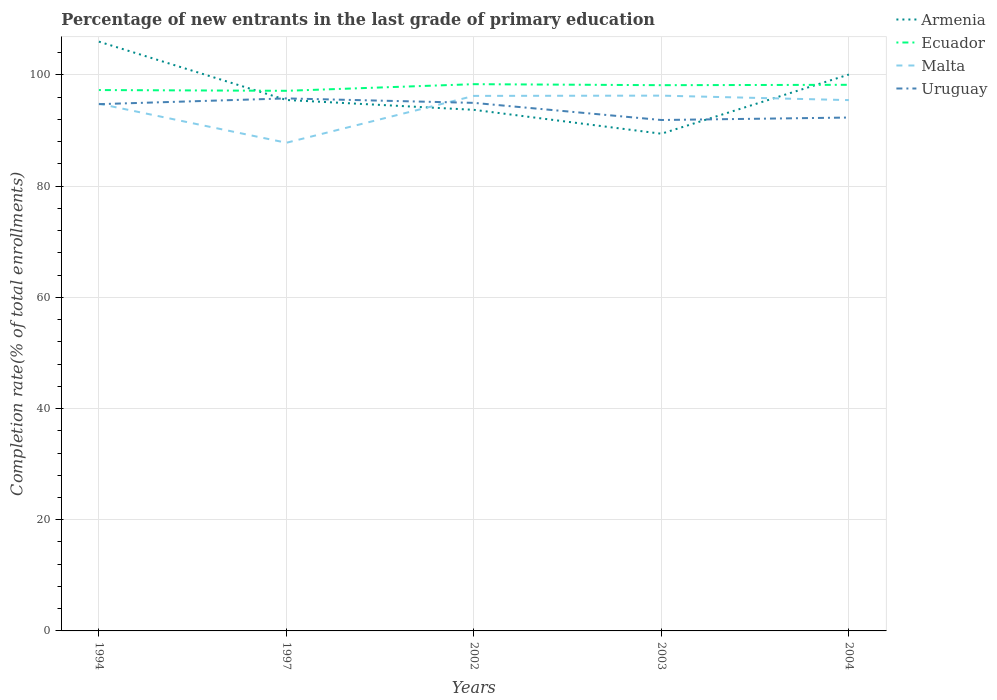Across all years, what is the maximum percentage of new entrants in Malta?
Your answer should be very brief. 87.8. In which year was the percentage of new entrants in Malta maximum?
Keep it short and to the point. 1997. What is the total percentage of new entrants in Uruguay in the graph?
Offer a terse response. 2.41. What is the difference between the highest and the second highest percentage of new entrants in Uruguay?
Offer a very short reply. 3.88. What is the difference between the highest and the lowest percentage of new entrants in Malta?
Provide a succinct answer. 4. Is the percentage of new entrants in Malta strictly greater than the percentage of new entrants in Armenia over the years?
Ensure brevity in your answer.  No. How many years are there in the graph?
Your answer should be compact. 5. What is the difference between two consecutive major ticks on the Y-axis?
Your response must be concise. 20. Does the graph contain any zero values?
Offer a terse response. No. Does the graph contain grids?
Offer a terse response. Yes. Where does the legend appear in the graph?
Offer a terse response. Top right. How many legend labels are there?
Keep it short and to the point. 4. What is the title of the graph?
Your answer should be compact. Percentage of new entrants in the last grade of primary education. Does "Uruguay" appear as one of the legend labels in the graph?
Your response must be concise. Yes. What is the label or title of the X-axis?
Make the answer very short. Years. What is the label or title of the Y-axis?
Provide a succinct answer. Completion rate(% of total enrollments). What is the Completion rate(% of total enrollments) of Armenia in 1994?
Your response must be concise. 105.99. What is the Completion rate(% of total enrollments) of Ecuador in 1994?
Offer a very short reply. 97.28. What is the Completion rate(% of total enrollments) of Malta in 1994?
Make the answer very short. 94.82. What is the Completion rate(% of total enrollments) of Uruguay in 1994?
Offer a terse response. 94.75. What is the Completion rate(% of total enrollments) of Armenia in 1997?
Give a very brief answer. 95.5. What is the Completion rate(% of total enrollments) of Ecuador in 1997?
Keep it short and to the point. 97.15. What is the Completion rate(% of total enrollments) of Malta in 1997?
Your response must be concise. 87.8. What is the Completion rate(% of total enrollments) of Uruguay in 1997?
Your response must be concise. 95.78. What is the Completion rate(% of total enrollments) of Armenia in 2002?
Keep it short and to the point. 93.73. What is the Completion rate(% of total enrollments) in Ecuador in 2002?
Offer a very short reply. 98.34. What is the Completion rate(% of total enrollments) of Malta in 2002?
Provide a succinct answer. 96.23. What is the Completion rate(% of total enrollments) of Uruguay in 2002?
Ensure brevity in your answer.  94.98. What is the Completion rate(% of total enrollments) of Armenia in 2003?
Keep it short and to the point. 89.43. What is the Completion rate(% of total enrollments) in Ecuador in 2003?
Your response must be concise. 98.16. What is the Completion rate(% of total enrollments) of Malta in 2003?
Your response must be concise. 96.28. What is the Completion rate(% of total enrollments) of Uruguay in 2003?
Make the answer very short. 91.9. What is the Completion rate(% of total enrollments) of Armenia in 2004?
Your response must be concise. 100.08. What is the Completion rate(% of total enrollments) of Ecuador in 2004?
Ensure brevity in your answer.  98.23. What is the Completion rate(% of total enrollments) in Malta in 2004?
Provide a short and direct response. 95.47. What is the Completion rate(% of total enrollments) of Uruguay in 2004?
Your answer should be very brief. 92.34. Across all years, what is the maximum Completion rate(% of total enrollments) of Armenia?
Offer a very short reply. 105.99. Across all years, what is the maximum Completion rate(% of total enrollments) of Ecuador?
Your response must be concise. 98.34. Across all years, what is the maximum Completion rate(% of total enrollments) in Malta?
Your response must be concise. 96.28. Across all years, what is the maximum Completion rate(% of total enrollments) of Uruguay?
Ensure brevity in your answer.  95.78. Across all years, what is the minimum Completion rate(% of total enrollments) of Armenia?
Your answer should be compact. 89.43. Across all years, what is the minimum Completion rate(% of total enrollments) of Ecuador?
Provide a succinct answer. 97.15. Across all years, what is the minimum Completion rate(% of total enrollments) of Malta?
Make the answer very short. 87.8. Across all years, what is the minimum Completion rate(% of total enrollments) in Uruguay?
Your answer should be compact. 91.9. What is the total Completion rate(% of total enrollments) of Armenia in the graph?
Ensure brevity in your answer.  484.72. What is the total Completion rate(% of total enrollments) in Ecuador in the graph?
Provide a succinct answer. 489.16. What is the total Completion rate(% of total enrollments) of Malta in the graph?
Make the answer very short. 470.61. What is the total Completion rate(% of total enrollments) in Uruguay in the graph?
Your response must be concise. 469.74. What is the difference between the Completion rate(% of total enrollments) of Armenia in 1994 and that in 1997?
Your answer should be compact. 10.49. What is the difference between the Completion rate(% of total enrollments) of Ecuador in 1994 and that in 1997?
Your answer should be compact. 0.14. What is the difference between the Completion rate(% of total enrollments) in Malta in 1994 and that in 1997?
Your response must be concise. 7.02. What is the difference between the Completion rate(% of total enrollments) in Uruguay in 1994 and that in 1997?
Offer a very short reply. -1.03. What is the difference between the Completion rate(% of total enrollments) in Armenia in 1994 and that in 2002?
Offer a very short reply. 12.27. What is the difference between the Completion rate(% of total enrollments) in Ecuador in 1994 and that in 2002?
Ensure brevity in your answer.  -1.06. What is the difference between the Completion rate(% of total enrollments) in Malta in 1994 and that in 2002?
Offer a terse response. -1.41. What is the difference between the Completion rate(% of total enrollments) of Uruguay in 1994 and that in 2002?
Provide a short and direct response. -0.23. What is the difference between the Completion rate(% of total enrollments) of Armenia in 1994 and that in 2003?
Your response must be concise. 16.56. What is the difference between the Completion rate(% of total enrollments) in Ecuador in 1994 and that in 2003?
Give a very brief answer. -0.88. What is the difference between the Completion rate(% of total enrollments) of Malta in 1994 and that in 2003?
Your answer should be compact. -1.46. What is the difference between the Completion rate(% of total enrollments) of Uruguay in 1994 and that in 2003?
Your response must be concise. 2.85. What is the difference between the Completion rate(% of total enrollments) of Armenia in 1994 and that in 2004?
Make the answer very short. 5.92. What is the difference between the Completion rate(% of total enrollments) in Ecuador in 1994 and that in 2004?
Give a very brief answer. -0.94. What is the difference between the Completion rate(% of total enrollments) in Malta in 1994 and that in 2004?
Your response must be concise. -0.65. What is the difference between the Completion rate(% of total enrollments) of Uruguay in 1994 and that in 2004?
Provide a short and direct response. 2.41. What is the difference between the Completion rate(% of total enrollments) in Armenia in 1997 and that in 2002?
Offer a very short reply. 1.77. What is the difference between the Completion rate(% of total enrollments) of Ecuador in 1997 and that in 2002?
Your answer should be compact. -1.19. What is the difference between the Completion rate(% of total enrollments) of Malta in 1997 and that in 2002?
Ensure brevity in your answer.  -8.43. What is the difference between the Completion rate(% of total enrollments) in Uruguay in 1997 and that in 2002?
Give a very brief answer. 0.8. What is the difference between the Completion rate(% of total enrollments) in Armenia in 1997 and that in 2003?
Your response must be concise. 6.07. What is the difference between the Completion rate(% of total enrollments) of Ecuador in 1997 and that in 2003?
Offer a terse response. -1.01. What is the difference between the Completion rate(% of total enrollments) in Malta in 1997 and that in 2003?
Provide a short and direct response. -8.47. What is the difference between the Completion rate(% of total enrollments) of Uruguay in 1997 and that in 2003?
Provide a short and direct response. 3.88. What is the difference between the Completion rate(% of total enrollments) in Armenia in 1997 and that in 2004?
Your answer should be compact. -4.58. What is the difference between the Completion rate(% of total enrollments) of Ecuador in 1997 and that in 2004?
Your answer should be compact. -1.08. What is the difference between the Completion rate(% of total enrollments) of Malta in 1997 and that in 2004?
Make the answer very short. -7.67. What is the difference between the Completion rate(% of total enrollments) of Uruguay in 1997 and that in 2004?
Keep it short and to the point. 3.44. What is the difference between the Completion rate(% of total enrollments) of Armenia in 2002 and that in 2003?
Offer a very short reply. 4.3. What is the difference between the Completion rate(% of total enrollments) of Ecuador in 2002 and that in 2003?
Provide a short and direct response. 0.18. What is the difference between the Completion rate(% of total enrollments) in Malta in 2002 and that in 2003?
Make the answer very short. -0.05. What is the difference between the Completion rate(% of total enrollments) in Uruguay in 2002 and that in 2003?
Give a very brief answer. 3.08. What is the difference between the Completion rate(% of total enrollments) in Armenia in 2002 and that in 2004?
Your response must be concise. -6.35. What is the difference between the Completion rate(% of total enrollments) of Ecuador in 2002 and that in 2004?
Provide a short and direct response. 0.11. What is the difference between the Completion rate(% of total enrollments) in Malta in 2002 and that in 2004?
Your answer should be very brief. 0.76. What is the difference between the Completion rate(% of total enrollments) in Uruguay in 2002 and that in 2004?
Keep it short and to the point. 2.64. What is the difference between the Completion rate(% of total enrollments) of Armenia in 2003 and that in 2004?
Your answer should be compact. -10.65. What is the difference between the Completion rate(% of total enrollments) in Ecuador in 2003 and that in 2004?
Provide a succinct answer. -0.07. What is the difference between the Completion rate(% of total enrollments) in Malta in 2003 and that in 2004?
Make the answer very short. 0.81. What is the difference between the Completion rate(% of total enrollments) in Uruguay in 2003 and that in 2004?
Offer a terse response. -0.44. What is the difference between the Completion rate(% of total enrollments) in Armenia in 1994 and the Completion rate(% of total enrollments) in Ecuador in 1997?
Ensure brevity in your answer.  8.84. What is the difference between the Completion rate(% of total enrollments) in Armenia in 1994 and the Completion rate(% of total enrollments) in Malta in 1997?
Your answer should be compact. 18.19. What is the difference between the Completion rate(% of total enrollments) of Armenia in 1994 and the Completion rate(% of total enrollments) of Uruguay in 1997?
Make the answer very short. 10.21. What is the difference between the Completion rate(% of total enrollments) of Ecuador in 1994 and the Completion rate(% of total enrollments) of Malta in 1997?
Offer a very short reply. 9.48. What is the difference between the Completion rate(% of total enrollments) in Ecuador in 1994 and the Completion rate(% of total enrollments) in Uruguay in 1997?
Provide a short and direct response. 1.5. What is the difference between the Completion rate(% of total enrollments) in Malta in 1994 and the Completion rate(% of total enrollments) in Uruguay in 1997?
Your answer should be very brief. -0.96. What is the difference between the Completion rate(% of total enrollments) of Armenia in 1994 and the Completion rate(% of total enrollments) of Ecuador in 2002?
Your answer should be very brief. 7.65. What is the difference between the Completion rate(% of total enrollments) of Armenia in 1994 and the Completion rate(% of total enrollments) of Malta in 2002?
Your answer should be compact. 9.76. What is the difference between the Completion rate(% of total enrollments) in Armenia in 1994 and the Completion rate(% of total enrollments) in Uruguay in 2002?
Provide a succinct answer. 11.02. What is the difference between the Completion rate(% of total enrollments) of Ecuador in 1994 and the Completion rate(% of total enrollments) of Malta in 2002?
Give a very brief answer. 1.05. What is the difference between the Completion rate(% of total enrollments) in Ecuador in 1994 and the Completion rate(% of total enrollments) in Uruguay in 2002?
Your answer should be very brief. 2.31. What is the difference between the Completion rate(% of total enrollments) in Malta in 1994 and the Completion rate(% of total enrollments) in Uruguay in 2002?
Ensure brevity in your answer.  -0.16. What is the difference between the Completion rate(% of total enrollments) of Armenia in 1994 and the Completion rate(% of total enrollments) of Ecuador in 2003?
Your answer should be very brief. 7.83. What is the difference between the Completion rate(% of total enrollments) in Armenia in 1994 and the Completion rate(% of total enrollments) in Malta in 2003?
Provide a short and direct response. 9.71. What is the difference between the Completion rate(% of total enrollments) in Armenia in 1994 and the Completion rate(% of total enrollments) in Uruguay in 2003?
Ensure brevity in your answer.  14.1. What is the difference between the Completion rate(% of total enrollments) of Ecuador in 1994 and the Completion rate(% of total enrollments) of Uruguay in 2003?
Your answer should be very brief. 5.39. What is the difference between the Completion rate(% of total enrollments) of Malta in 1994 and the Completion rate(% of total enrollments) of Uruguay in 2003?
Your answer should be very brief. 2.93. What is the difference between the Completion rate(% of total enrollments) in Armenia in 1994 and the Completion rate(% of total enrollments) in Ecuador in 2004?
Make the answer very short. 7.77. What is the difference between the Completion rate(% of total enrollments) in Armenia in 1994 and the Completion rate(% of total enrollments) in Malta in 2004?
Provide a short and direct response. 10.52. What is the difference between the Completion rate(% of total enrollments) of Armenia in 1994 and the Completion rate(% of total enrollments) of Uruguay in 2004?
Ensure brevity in your answer.  13.65. What is the difference between the Completion rate(% of total enrollments) in Ecuador in 1994 and the Completion rate(% of total enrollments) in Malta in 2004?
Give a very brief answer. 1.81. What is the difference between the Completion rate(% of total enrollments) of Ecuador in 1994 and the Completion rate(% of total enrollments) of Uruguay in 2004?
Offer a terse response. 4.95. What is the difference between the Completion rate(% of total enrollments) in Malta in 1994 and the Completion rate(% of total enrollments) in Uruguay in 2004?
Make the answer very short. 2.48. What is the difference between the Completion rate(% of total enrollments) of Armenia in 1997 and the Completion rate(% of total enrollments) of Ecuador in 2002?
Ensure brevity in your answer.  -2.84. What is the difference between the Completion rate(% of total enrollments) of Armenia in 1997 and the Completion rate(% of total enrollments) of Malta in 2002?
Offer a terse response. -0.74. What is the difference between the Completion rate(% of total enrollments) of Armenia in 1997 and the Completion rate(% of total enrollments) of Uruguay in 2002?
Give a very brief answer. 0.52. What is the difference between the Completion rate(% of total enrollments) of Ecuador in 1997 and the Completion rate(% of total enrollments) of Malta in 2002?
Ensure brevity in your answer.  0.91. What is the difference between the Completion rate(% of total enrollments) in Ecuador in 1997 and the Completion rate(% of total enrollments) in Uruguay in 2002?
Offer a terse response. 2.17. What is the difference between the Completion rate(% of total enrollments) in Malta in 1997 and the Completion rate(% of total enrollments) in Uruguay in 2002?
Ensure brevity in your answer.  -7.17. What is the difference between the Completion rate(% of total enrollments) of Armenia in 1997 and the Completion rate(% of total enrollments) of Ecuador in 2003?
Your response must be concise. -2.66. What is the difference between the Completion rate(% of total enrollments) in Armenia in 1997 and the Completion rate(% of total enrollments) in Malta in 2003?
Provide a succinct answer. -0.78. What is the difference between the Completion rate(% of total enrollments) in Armenia in 1997 and the Completion rate(% of total enrollments) in Uruguay in 2003?
Your answer should be compact. 3.6. What is the difference between the Completion rate(% of total enrollments) of Ecuador in 1997 and the Completion rate(% of total enrollments) of Malta in 2003?
Keep it short and to the point. 0.87. What is the difference between the Completion rate(% of total enrollments) of Ecuador in 1997 and the Completion rate(% of total enrollments) of Uruguay in 2003?
Offer a terse response. 5.25. What is the difference between the Completion rate(% of total enrollments) in Malta in 1997 and the Completion rate(% of total enrollments) in Uruguay in 2003?
Offer a very short reply. -4.09. What is the difference between the Completion rate(% of total enrollments) in Armenia in 1997 and the Completion rate(% of total enrollments) in Ecuador in 2004?
Your response must be concise. -2.73. What is the difference between the Completion rate(% of total enrollments) in Armenia in 1997 and the Completion rate(% of total enrollments) in Malta in 2004?
Make the answer very short. 0.02. What is the difference between the Completion rate(% of total enrollments) of Armenia in 1997 and the Completion rate(% of total enrollments) of Uruguay in 2004?
Ensure brevity in your answer.  3.16. What is the difference between the Completion rate(% of total enrollments) of Ecuador in 1997 and the Completion rate(% of total enrollments) of Malta in 2004?
Your answer should be compact. 1.67. What is the difference between the Completion rate(% of total enrollments) in Ecuador in 1997 and the Completion rate(% of total enrollments) in Uruguay in 2004?
Your answer should be very brief. 4.81. What is the difference between the Completion rate(% of total enrollments) in Malta in 1997 and the Completion rate(% of total enrollments) in Uruguay in 2004?
Give a very brief answer. -4.53. What is the difference between the Completion rate(% of total enrollments) of Armenia in 2002 and the Completion rate(% of total enrollments) of Ecuador in 2003?
Make the answer very short. -4.43. What is the difference between the Completion rate(% of total enrollments) in Armenia in 2002 and the Completion rate(% of total enrollments) in Malta in 2003?
Offer a very short reply. -2.55. What is the difference between the Completion rate(% of total enrollments) of Armenia in 2002 and the Completion rate(% of total enrollments) of Uruguay in 2003?
Provide a short and direct response. 1.83. What is the difference between the Completion rate(% of total enrollments) in Ecuador in 2002 and the Completion rate(% of total enrollments) in Malta in 2003?
Ensure brevity in your answer.  2.06. What is the difference between the Completion rate(% of total enrollments) of Ecuador in 2002 and the Completion rate(% of total enrollments) of Uruguay in 2003?
Offer a very short reply. 6.44. What is the difference between the Completion rate(% of total enrollments) of Malta in 2002 and the Completion rate(% of total enrollments) of Uruguay in 2003?
Your response must be concise. 4.34. What is the difference between the Completion rate(% of total enrollments) in Armenia in 2002 and the Completion rate(% of total enrollments) in Ecuador in 2004?
Provide a short and direct response. -4.5. What is the difference between the Completion rate(% of total enrollments) of Armenia in 2002 and the Completion rate(% of total enrollments) of Malta in 2004?
Keep it short and to the point. -1.75. What is the difference between the Completion rate(% of total enrollments) in Armenia in 2002 and the Completion rate(% of total enrollments) in Uruguay in 2004?
Provide a short and direct response. 1.39. What is the difference between the Completion rate(% of total enrollments) of Ecuador in 2002 and the Completion rate(% of total enrollments) of Malta in 2004?
Your response must be concise. 2.87. What is the difference between the Completion rate(% of total enrollments) of Ecuador in 2002 and the Completion rate(% of total enrollments) of Uruguay in 2004?
Ensure brevity in your answer.  6. What is the difference between the Completion rate(% of total enrollments) in Malta in 2002 and the Completion rate(% of total enrollments) in Uruguay in 2004?
Ensure brevity in your answer.  3.9. What is the difference between the Completion rate(% of total enrollments) in Armenia in 2003 and the Completion rate(% of total enrollments) in Ecuador in 2004?
Ensure brevity in your answer.  -8.8. What is the difference between the Completion rate(% of total enrollments) in Armenia in 2003 and the Completion rate(% of total enrollments) in Malta in 2004?
Offer a very short reply. -6.05. What is the difference between the Completion rate(% of total enrollments) in Armenia in 2003 and the Completion rate(% of total enrollments) in Uruguay in 2004?
Your answer should be compact. -2.91. What is the difference between the Completion rate(% of total enrollments) of Ecuador in 2003 and the Completion rate(% of total enrollments) of Malta in 2004?
Make the answer very short. 2.69. What is the difference between the Completion rate(% of total enrollments) of Ecuador in 2003 and the Completion rate(% of total enrollments) of Uruguay in 2004?
Your response must be concise. 5.82. What is the difference between the Completion rate(% of total enrollments) of Malta in 2003 and the Completion rate(% of total enrollments) of Uruguay in 2004?
Offer a terse response. 3.94. What is the average Completion rate(% of total enrollments) in Armenia per year?
Ensure brevity in your answer.  96.94. What is the average Completion rate(% of total enrollments) of Ecuador per year?
Make the answer very short. 97.83. What is the average Completion rate(% of total enrollments) in Malta per year?
Provide a succinct answer. 94.12. What is the average Completion rate(% of total enrollments) in Uruguay per year?
Keep it short and to the point. 93.95. In the year 1994, what is the difference between the Completion rate(% of total enrollments) of Armenia and Completion rate(% of total enrollments) of Ecuador?
Make the answer very short. 8.71. In the year 1994, what is the difference between the Completion rate(% of total enrollments) in Armenia and Completion rate(% of total enrollments) in Malta?
Offer a terse response. 11.17. In the year 1994, what is the difference between the Completion rate(% of total enrollments) of Armenia and Completion rate(% of total enrollments) of Uruguay?
Offer a terse response. 11.25. In the year 1994, what is the difference between the Completion rate(% of total enrollments) in Ecuador and Completion rate(% of total enrollments) in Malta?
Offer a very short reply. 2.46. In the year 1994, what is the difference between the Completion rate(% of total enrollments) in Ecuador and Completion rate(% of total enrollments) in Uruguay?
Make the answer very short. 2.54. In the year 1994, what is the difference between the Completion rate(% of total enrollments) in Malta and Completion rate(% of total enrollments) in Uruguay?
Make the answer very short. 0.08. In the year 1997, what is the difference between the Completion rate(% of total enrollments) of Armenia and Completion rate(% of total enrollments) of Ecuador?
Offer a very short reply. -1.65. In the year 1997, what is the difference between the Completion rate(% of total enrollments) of Armenia and Completion rate(% of total enrollments) of Malta?
Give a very brief answer. 7.69. In the year 1997, what is the difference between the Completion rate(% of total enrollments) in Armenia and Completion rate(% of total enrollments) in Uruguay?
Ensure brevity in your answer.  -0.28. In the year 1997, what is the difference between the Completion rate(% of total enrollments) of Ecuador and Completion rate(% of total enrollments) of Malta?
Your answer should be compact. 9.34. In the year 1997, what is the difference between the Completion rate(% of total enrollments) in Ecuador and Completion rate(% of total enrollments) in Uruguay?
Offer a very short reply. 1.37. In the year 1997, what is the difference between the Completion rate(% of total enrollments) in Malta and Completion rate(% of total enrollments) in Uruguay?
Your answer should be compact. -7.98. In the year 2002, what is the difference between the Completion rate(% of total enrollments) in Armenia and Completion rate(% of total enrollments) in Ecuador?
Your answer should be very brief. -4.62. In the year 2002, what is the difference between the Completion rate(% of total enrollments) in Armenia and Completion rate(% of total enrollments) in Malta?
Provide a succinct answer. -2.51. In the year 2002, what is the difference between the Completion rate(% of total enrollments) in Armenia and Completion rate(% of total enrollments) in Uruguay?
Your answer should be compact. -1.25. In the year 2002, what is the difference between the Completion rate(% of total enrollments) in Ecuador and Completion rate(% of total enrollments) in Malta?
Keep it short and to the point. 2.11. In the year 2002, what is the difference between the Completion rate(% of total enrollments) of Ecuador and Completion rate(% of total enrollments) of Uruguay?
Offer a terse response. 3.36. In the year 2002, what is the difference between the Completion rate(% of total enrollments) of Malta and Completion rate(% of total enrollments) of Uruguay?
Provide a succinct answer. 1.26. In the year 2003, what is the difference between the Completion rate(% of total enrollments) in Armenia and Completion rate(% of total enrollments) in Ecuador?
Provide a short and direct response. -8.73. In the year 2003, what is the difference between the Completion rate(% of total enrollments) of Armenia and Completion rate(% of total enrollments) of Malta?
Provide a short and direct response. -6.85. In the year 2003, what is the difference between the Completion rate(% of total enrollments) of Armenia and Completion rate(% of total enrollments) of Uruguay?
Offer a terse response. -2.47. In the year 2003, what is the difference between the Completion rate(% of total enrollments) in Ecuador and Completion rate(% of total enrollments) in Malta?
Provide a short and direct response. 1.88. In the year 2003, what is the difference between the Completion rate(% of total enrollments) in Ecuador and Completion rate(% of total enrollments) in Uruguay?
Your answer should be very brief. 6.26. In the year 2003, what is the difference between the Completion rate(% of total enrollments) of Malta and Completion rate(% of total enrollments) of Uruguay?
Keep it short and to the point. 4.38. In the year 2004, what is the difference between the Completion rate(% of total enrollments) of Armenia and Completion rate(% of total enrollments) of Ecuador?
Offer a very short reply. 1.85. In the year 2004, what is the difference between the Completion rate(% of total enrollments) of Armenia and Completion rate(% of total enrollments) of Malta?
Your answer should be compact. 4.6. In the year 2004, what is the difference between the Completion rate(% of total enrollments) in Armenia and Completion rate(% of total enrollments) in Uruguay?
Keep it short and to the point. 7.74. In the year 2004, what is the difference between the Completion rate(% of total enrollments) in Ecuador and Completion rate(% of total enrollments) in Malta?
Make the answer very short. 2.75. In the year 2004, what is the difference between the Completion rate(% of total enrollments) of Ecuador and Completion rate(% of total enrollments) of Uruguay?
Provide a short and direct response. 5.89. In the year 2004, what is the difference between the Completion rate(% of total enrollments) of Malta and Completion rate(% of total enrollments) of Uruguay?
Your answer should be very brief. 3.14. What is the ratio of the Completion rate(% of total enrollments) in Armenia in 1994 to that in 1997?
Ensure brevity in your answer.  1.11. What is the ratio of the Completion rate(% of total enrollments) of Malta in 1994 to that in 1997?
Give a very brief answer. 1.08. What is the ratio of the Completion rate(% of total enrollments) in Armenia in 1994 to that in 2002?
Offer a terse response. 1.13. What is the ratio of the Completion rate(% of total enrollments) of Ecuador in 1994 to that in 2002?
Your answer should be very brief. 0.99. What is the ratio of the Completion rate(% of total enrollments) of Armenia in 1994 to that in 2003?
Your answer should be compact. 1.19. What is the ratio of the Completion rate(% of total enrollments) in Malta in 1994 to that in 2003?
Give a very brief answer. 0.98. What is the ratio of the Completion rate(% of total enrollments) of Uruguay in 1994 to that in 2003?
Provide a short and direct response. 1.03. What is the ratio of the Completion rate(% of total enrollments) in Armenia in 1994 to that in 2004?
Provide a short and direct response. 1.06. What is the ratio of the Completion rate(% of total enrollments) of Ecuador in 1994 to that in 2004?
Offer a very short reply. 0.99. What is the ratio of the Completion rate(% of total enrollments) in Malta in 1994 to that in 2004?
Provide a succinct answer. 0.99. What is the ratio of the Completion rate(% of total enrollments) in Uruguay in 1994 to that in 2004?
Offer a very short reply. 1.03. What is the ratio of the Completion rate(% of total enrollments) of Armenia in 1997 to that in 2002?
Your answer should be very brief. 1.02. What is the ratio of the Completion rate(% of total enrollments) of Ecuador in 1997 to that in 2002?
Your response must be concise. 0.99. What is the ratio of the Completion rate(% of total enrollments) of Malta in 1997 to that in 2002?
Your response must be concise. 0.91. What is the ratio of the Completion rate(% of total enrollments) of Uruguay in 1997 to that in 2002?
Provide a succinct answer. 1.01. What is the ratio of the Completion rate(% of total enrollments) in Armenia in 1997 to that in 2003?
Keep it short and to the point. 1.07. What is the ratio of the Completion rate(% of total enrollments) in Malta in 1997 to that in 2003?
Your answer should be compact. 0.91. What is the ratio of the Completion rate(% of total enrollments) of Uruguay in 1997 to that in 2003?
Give a very brief answer. 1.04. What is the ratio of the Completion rate(% of total enrollments) in Armenia in 1997 to that in 2004?
Keep it short and to the point. 0.95. What is the ratio of the Completion rate(% of total enrollments) in Malta in 1997 to that in 2004?
Provide a succinct answer. 0.92. What is the ratio of the Completion rate(% of total enrollments) in Uruguay in 1997 to that in 2004?
Ensure brevity in your answer.  1.04. What is the ratio of the Completion rate(% of total enrollments) in Armenia in 2002 to that in 2003?
Make the answer very short. 1.05. What is the ratio of the Completion rate(% of total enrollments) in Ecuador in 2002 to that in 2003?
Provide a succinct answer. 1. What is the ratio of the Completion rate(% of total enrollments) of Uruguay in 2002 to that in 2003?
Your answer should be compact. 1.03. What is the ratio of the Completion rate(% of total enrollments) of Armenia in 2002 to that in 2004?
Offer a terse response. 0.94. What is the ratio of the Completion rate(% of total enrollments) in Ecuador in 2002 to that in 2004?
Give a very brief answer. 1. What is the ratio of the Completion rate(% of total enrollments) in Uruguay in 2002 to that in 2004?
Your answer should be compact. 1.03. What is the ratio of the Completion rate(% of total enrollments) in Armenia in 2003 to that in 2004?
Provide a succinct answer. 0.89. What is the ratio of the Completion rate(% of total enrollments) of Malta in 2003 to that in 2004?
Your answer should be very brief. 1.01. What is the ratio of the Completion rate(% of total enrollments) in Uruguay in 2003 to that in 2004?
Your answer should be very brief. 1. What is the difference between the highest and the second highest Completion rate(% of total enrollments) in Armenia?
Your answer should be compact. 5.92. What is the difference between the highest and the second highest Completion rate(% of total enrollments) of Ecuador?
Give a very brief answer. 0.11. What is the difference between the highest and the second highest Completion rate(% of total enrollments) in Malta?
Ensure brevity in your answer.  0.05. What is the difference between the highest and the second highest Completion rate(% of total enrollments) in Uruguay?
Offer a terse response. 0.8. What is the difference between the highest and the lowest Completion rate(% of total enrollments) of Armenia?
Your response must be concise. 16.56. What is the difference between the highest and the lowest Completion rate(% of total enrollments) in Ecuador?
Keep it short and to the point. 1.19. What is the difference between the highest and the lowest Completion rate(% of total enrollments) of Malta?
Your answer should be compact. 8.47. What is the difference between the highest and the lowest Completion rate(% of total enrollments) of Uruguay?
Your answer should be very brief. 3.88. 